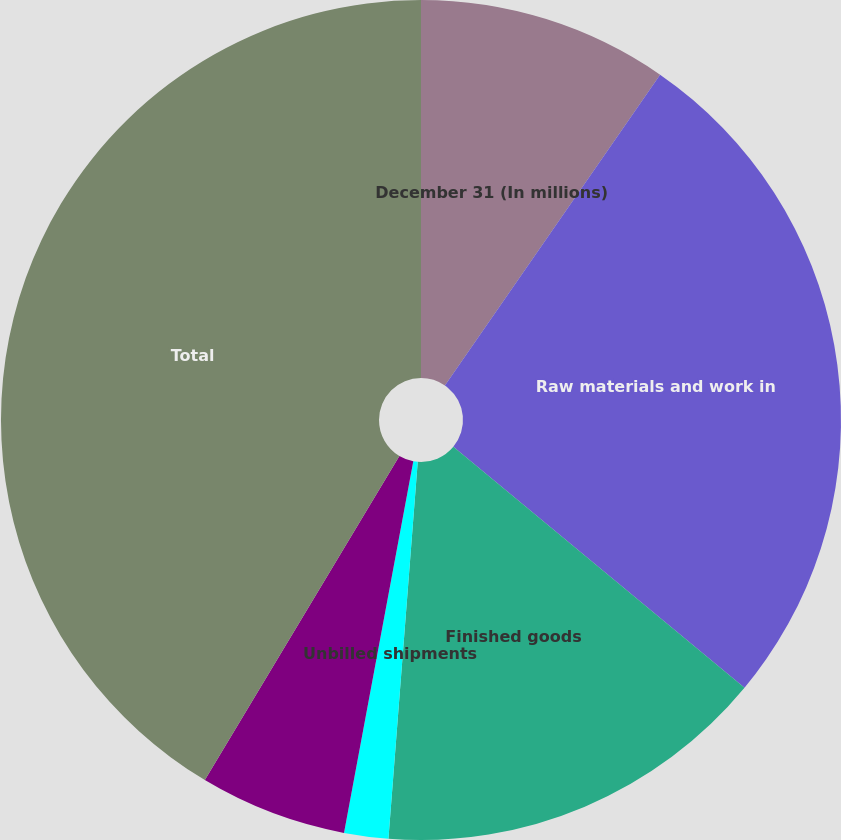<chart> <loc_0><loc_0><loc_500><loc_500><pie_chart><fcel>December 31 (In millions)<fcel>Raw materials and work in<fcel>Finished goods<fcel>Unbilled shipments<fcel>Less revaluation to LIFO<fcel>Total<nl><fcel>9.64%<fcel>26.37%<fcel>15.23%<fcel>1.7%<fcel>5.67%<fcel>41.4%<nl></chart> 